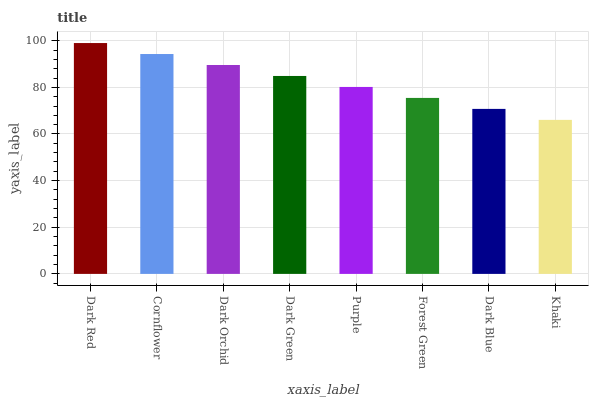Is Khaki the minimum?
Answer yes or no. Yes. Is Dark Red the maximum?
Answer yes or no. Yes. Is Cornflower the minimum?
Answer yes or no. No. Is Cornflower the maximum?
Answer yes or no. No. Is Dark Red greater than Cornflower?
Answer yes or no. Yes. Is Cornflower less than Dark Red?
Answer yes or no. Yes. Is Cornflower greater than Dark Red?
Answer yes or no. No. Is Dark Red less than Cornflower?
Answer yes or no. No. Is Dark Green the high median?
Answer yes or no. Yes. Is Purple the low median?
Answer yes or no. Yes. Is Dark Blue the high median?
Answer yes or no. No. Is Cornflower the low median?
Answer yes or no. No. 